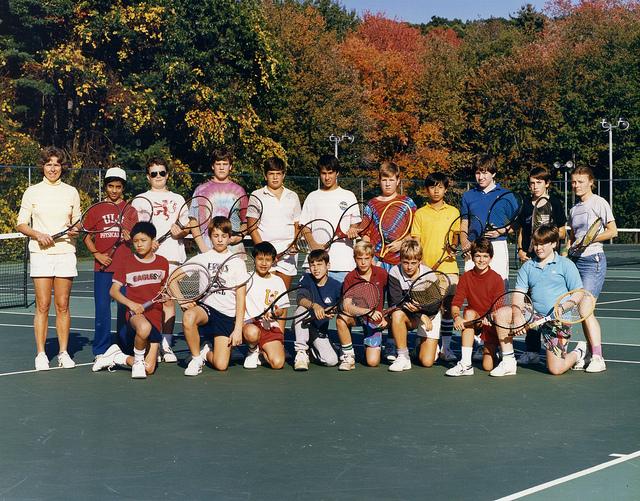Are they on a hill?
Keep it brief. No. How many women are in this scene?
Keep it brief. 2. What is everyone holding?
Keep it brief. Tennis rackets. What sport is being shown?
Short answer required. Tennis. 